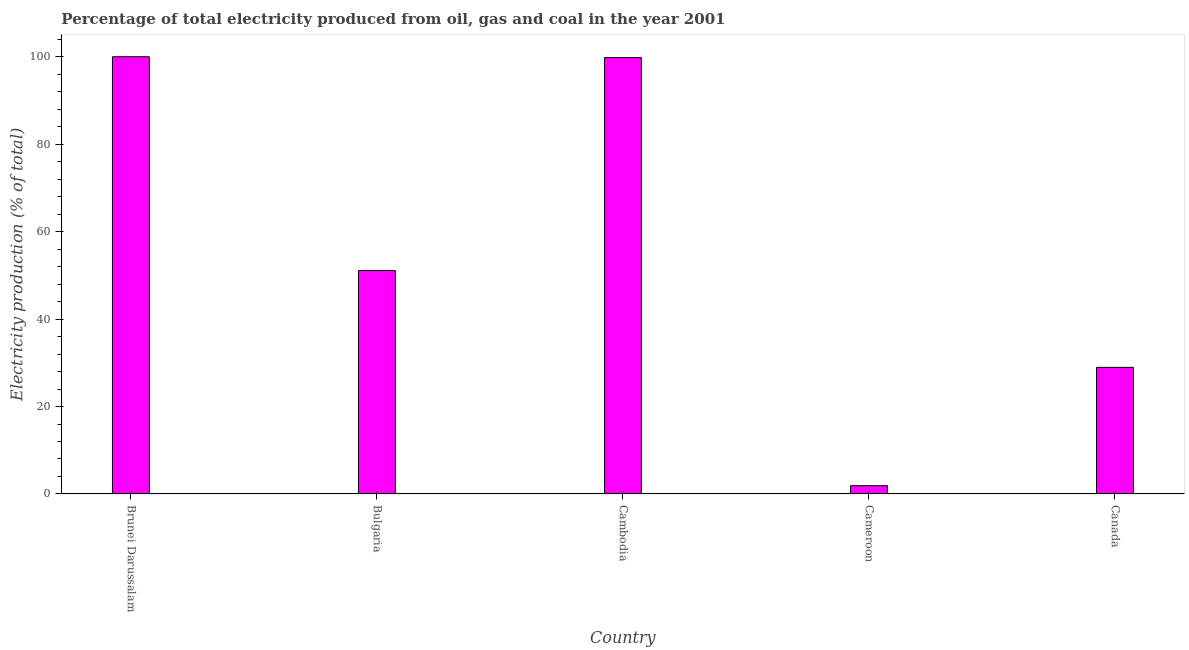Does the graph contain any zero values?
Offer a very short reply. No. What is the title of the graph?
Offer a very short reply. Percentage of total electricity produced from oil, gas and coal in the year 2001. What is the label or title of the X-axis?
Make the answer very short. Country. What is the label or title of the Y-axis?
Your response must be concise. Electricity production (% of total). What is the electricity production in Bulgaria?
Your answer should be very brief. 51.1. Across all countries, what is the minimum electricity production?
Your answer should be compact. 1.89. In which country was the electricity production maximum?
Offer a terse response. Brunei Darussalam. In which country was the electricity production minimum?
Provide a succinct answer. Cameroon. What is the sum of the electricity production?
Provide a succinct answer. 281.75. What is the difference between the electricity production in Brunei Darussalam and Cameroon?
Offer a very short reply. 98.11. What is the average electricity production per country?
Your response must be concise. 56.35. What is the median electricity production?
Your response must be concise. 51.1. What is the ratio of the electricity production in Cambodia to that in Canada?
Keep it short and to the point. 3.45. Is the difference between the electricity production in Cameroon and Canada greater than the difference between any two countries?
Offer a very short reply. No. What is the difference between the highest and the second highest electricity production?
Provide a succinct answer. 0.2. Is the sum of the electricity production in Brunei Darussalam and Cameroon greater than the maximum electricity production across all countries?
Your answer should be very brief. Yes. What is the difference between the highest and the lowest electricity production?
Provide a succinct answer. 98.11. How many bars are there?
Make the answer very short. 5. Are all the bars in the graph horizontal?
Make the answer very short. No. What is the Electricity production (% of total) of Bulgaria?
Provide a short and direct response. 51.1. What is the Electricity production (% of total) of Cambodia?
Offer a very short reply. 99.8. What is the Electricity production (% of total) of Cameroon?
Offer a terse response. 1.89. What is the Electricity production (% of total) in Canada?
Give a very brief answer. 28.95. What is the difference between the Electricity production (% of total) in Brunei Darussalam and Bulgaria?
Make the answer very short. 48.9. What is the difference between the Electricity production (% of total) in Brunei Darussalam and Cambodia?
Your answer should be very brief. 0.2. What is the difference between the Electricity production (% of total) in Brunei Darussalam and Cameroon?
Provide a short and direct response. 98.11. What is the difference between the Electricity production (% of total) in Brunei Darussalam and Canada?
Offer a terse response. 71.05. What is the difference between the Electricity production (% of total) in Bulgaria and Cambodia?
Make the answer very short. -48.71. What is the difference between the Electricity production (% of total) in Bulgaria and Cameroon?
Offer a very short reply. 49.2. What is the difference between the Electricity production (% of total) in Bulgaria and Canada?
Your response must be concise. 22.14. What is the difference between the Electricity production (% of total) in Cambodia and Cameroon?
Provide a succinct answer. 97.91. What is the difference between the Electricity production (% of total) in Cambodia and Canada?
Offer a terse response. 70.85. What is the difference between the Electricity production (% of total) in Cameroon and Canada?
Offer a terse response. -27.06. What is the ratio of the Electricity production (% of total) in Brunei Darussalam to that in Bulgaria?
Keep it short and to the point. 1.96. What is the ratio of the Electricity production (% of total) in Brunei Darussalam to that in Cambodia?
Your answer should be compact. 1. What is the ratio of the Electricity production (% of total) in Brunei Darussalam to that in Cameroon?
Your response must be concise. 52.85. What is the ratio of the Electricity production (% of total) in Brunei Darussalam to that in Canada?
Ensure brevity in your answer.  3.45. What is the ratio of the Electricity production (% of total) in Bulgaria to that in Cambodia?
Make the answer very short. 0.51. What is the ratio of the Electricity production (% of total) in Bulgaria to that in Cameroon?
Provide a succinct answer. 27. What is the ratio of the Electricity production (% of total) in Bulgaria to that in Canada?
Give a very brief answer. 1.76. What is the ratio of the Electricity production (% of total) in Cambodia to that in Cameroon?
Your response must be concise. 52.75. What is the ratio of the Electricity production (% of total) in Cambodia to that in Canada?
Provide a short and direct response. 3.45. What is the ratio of the Electricity production (% of total) in Cameroon to that in Canada?
Make the answer very short. 0.07. 